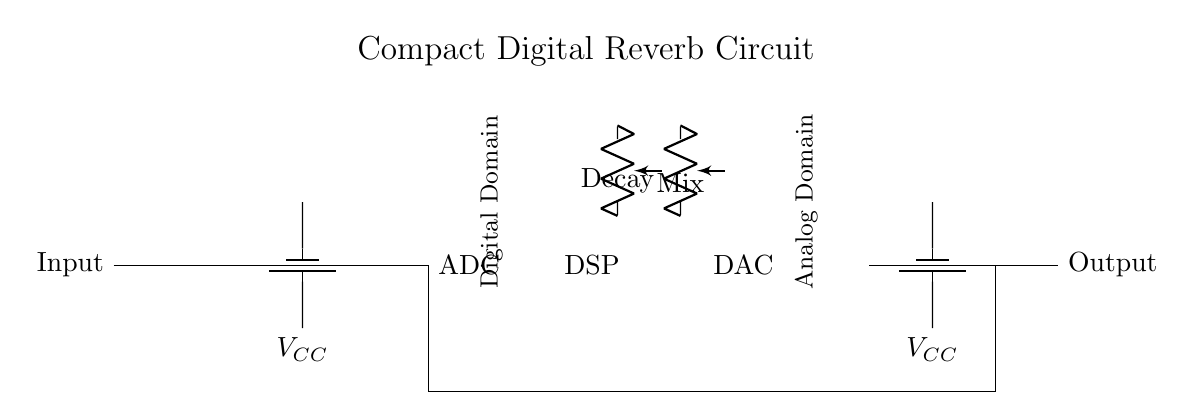What is the main function of the DSP in this circuit? The DSP, or Digital Signal Processor, is responsible for processing the digital audio signal to create the reverb effect. It analyzes the incoming signal and applies the desired algorithms for the desired acoustic enhancement.
Answer: Digital Signal Processing How many resistive elements are present in the circuit? There are two resistive elements present in the form of potentiometers labeled Decay and Mix. They are used to adjust the parameters of the reverb effect.
Answer: Two What is the role of the ADC in this setup? The ADC, or Analog to Digital Converter, converts the incoming analog audio signal into a digital signal so that the DSP can process it. This is a crucial step for digital audio effects.
Answer: Signal conversion What components are used to buffer the signal before and after the DSP? The signal is buffered using operational amplifiers at the input and output of the DSP, ensuring signal integrity and preventing loading effects on the circuit.
Answer: Operational amplifiers What type of circuit is this? This is a compact digital reverb circuit designed for live audio applications, focusing on enhancing the acoustic environment through digital audio processing.
Answer: Digital reverb What voltage supplies are present in the circuit? The circuit has power supplied by two voltage sources denoted as VCC, which is needed to power the operational amplifiers, ADC, DSP, and DAC.
Answer: VCC What adjustable parameters are indicated in the circuit? The circuit indicates two adjustable parameters: Decay and Mix, which allow the user to modify the characteristics of the reverb effect in real-time.
Answer: Decay and Mix 